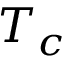<formula> <loc_0><loc_0><loc_500><loc_500>T _ { c }</formula> 